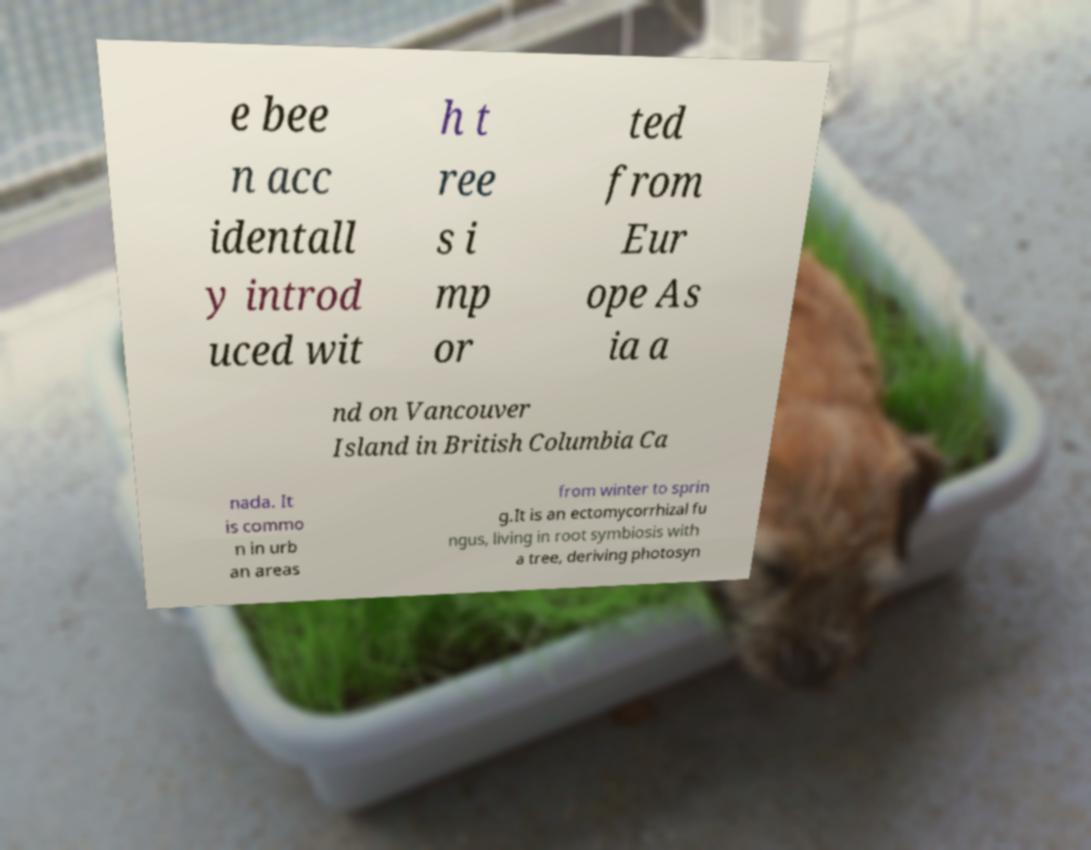For documentation purposes, I need the text within this image transcribed. Could you provide that? e bee n acc identall y introd uced wit h t ree s i mp or ted from Eur ope As ia a nd on Vancouver Island in British Columbia Ca nada. It is commo n in urb an areas from winter to sprin g.It is an ectomycorrhizal fu ngus, living in root symbiosis with a tree, deriving photosyn 